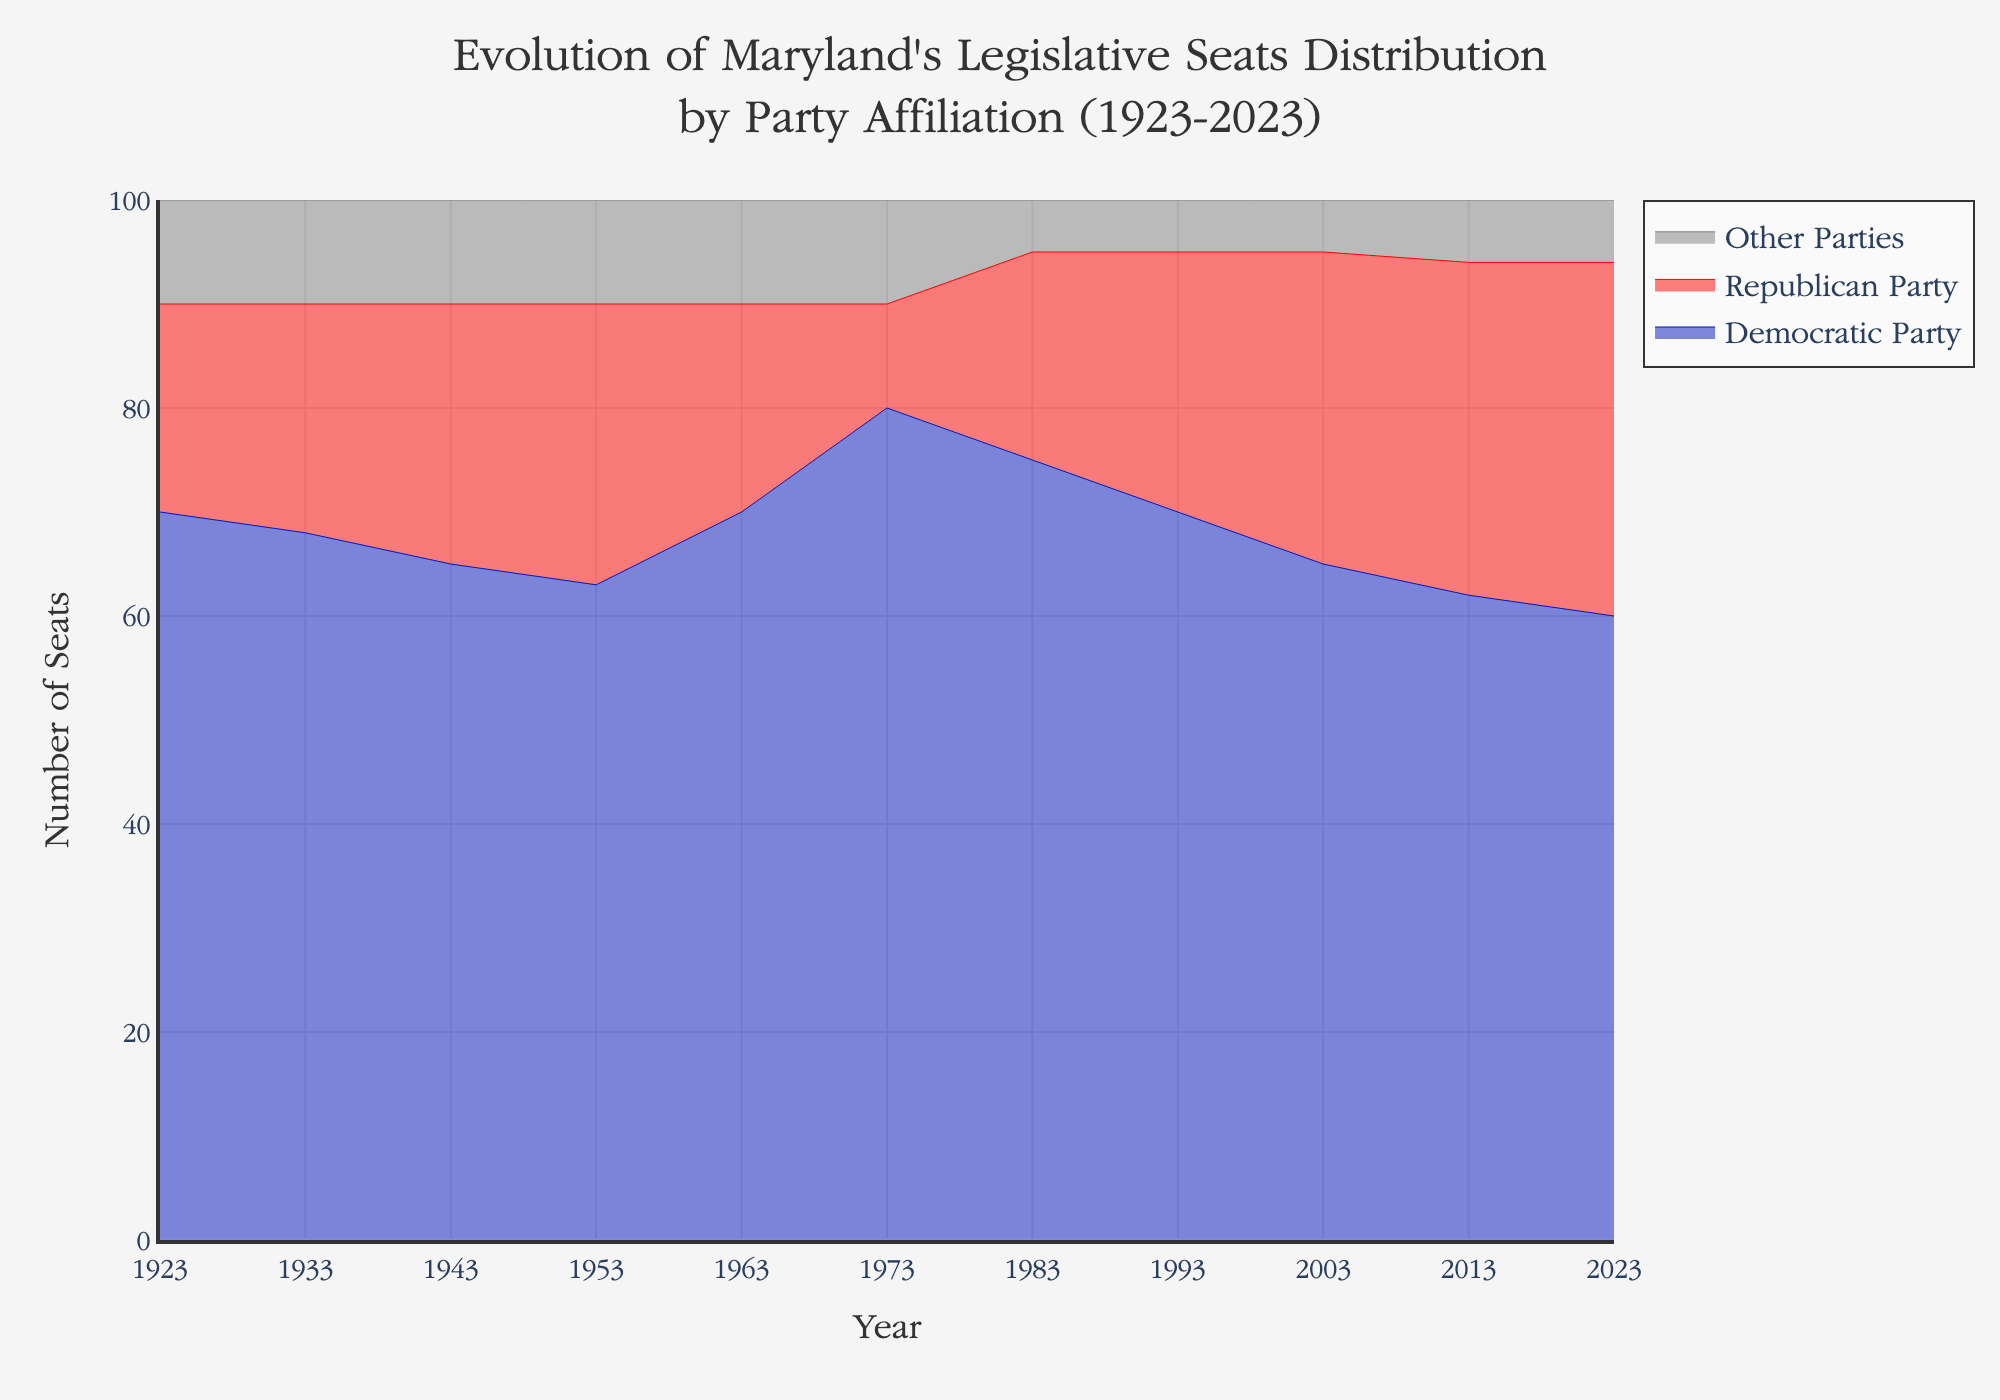What is the title of the figure? The title of the figure is located at the top and provides a brief description of what the graph depicts.
Answer: Evolution of Maryland's Legislative Seats Distribution by Party Affiliation (1923-2023) What is the range of years displayed on the x-axis? The x-axis shows the timeline over which the data points are distributed.
Answer: 1923 to 2023 How many years have data points represented in the figure? Count the distinct years along the timeline.
Answer: 11 Which party had the maximum number of seats in 1973? Look at the values for each party in the year 1973 and identify which is the highest.
Answer: Democratic Party In which year did the Republican Party have the highest number of seats? Identify the peak value for the Republican Party and note the corresponding year.
Answer: 2023 How did the number of seats for "Other Parties" change over the years? Observe the trend line for Other Parties, noting any increases or decreases.
Answer: Remained largely stable, with a slight decrease in 1983 By how many seats did the Democratic Party's representation decrease from 1923 to 2023? Subtract the number of seats in 2023 from the number in 1923 for the Democratic Party.
Answer: 10 In which year did the Democratic Party see a significant increase in seats compared to the previous decade? Compare the Democratic Party's seat values for each decade and identify the year with the largest increase.
Answer: 1963 How did the combined seats of the Democratic and Republican parties change from 2003 to 2013? Add the seats for both parties for 2003 and 2013, and then find the difference.
Answer: Decreased by 3 seats (95 to 92) How many seats did "Other Parties" gain from 2003 to 2023, and what might that indicate? Subtract the number of Other Parties' seats in 2003 from the number in 2023 and interpret the pattern.
Answer: Gained 1 seat, indicating minimal growth or consistent performance 